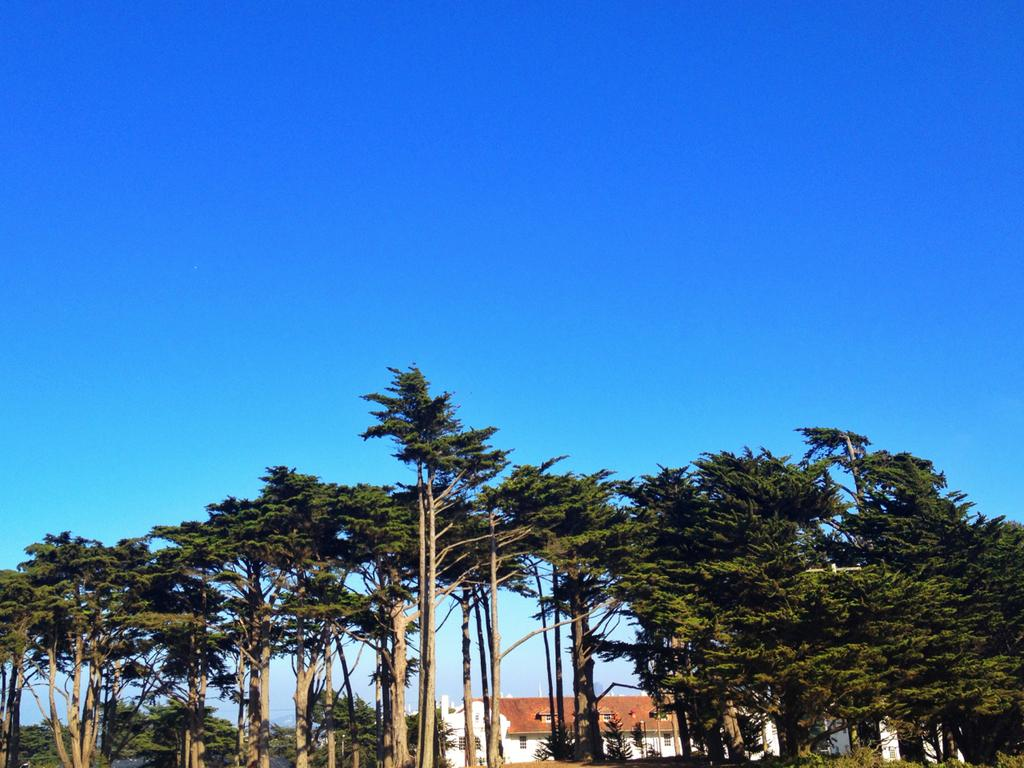What type of vegetation is present in the image? There are tall trees in the image. What structure can be seen behind the trees? There is a big house behind the trees. What part of the natural environment is visible in the image? The sky is visible in the background of the image. How many books are stacked on the line in the image? There are no books or lines present in the image; it features tall trees and a big house. 